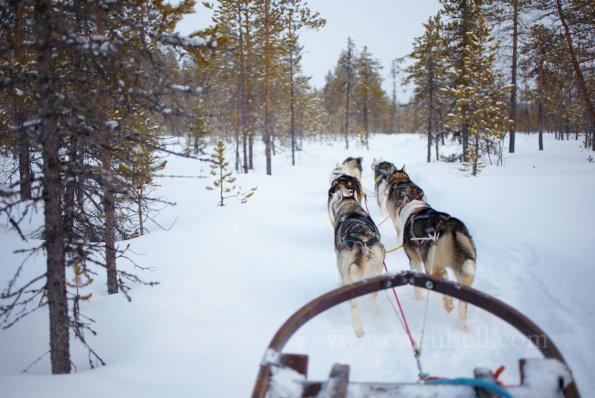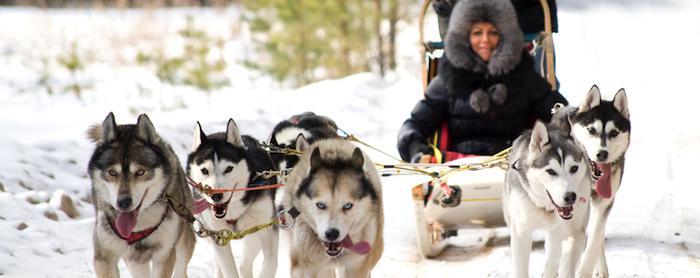The first image is the image on the left, the second image is the image on the right. Evaluate the accuracy of this statement regarding the images: "There is a person visible behind a pack of huskies.". Is it true? Answer yes or no. Yes. The first image is the image on the left, the second image is the image on the right. Examine the images to the left and right. Is the description "The image on the left has more than six dogs pulling the sleigh." accurate? Answer yes or no. No. 